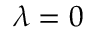<formula> <loc_0><loc_0><loc_500><loc_500>\lambda = 0</formula> 